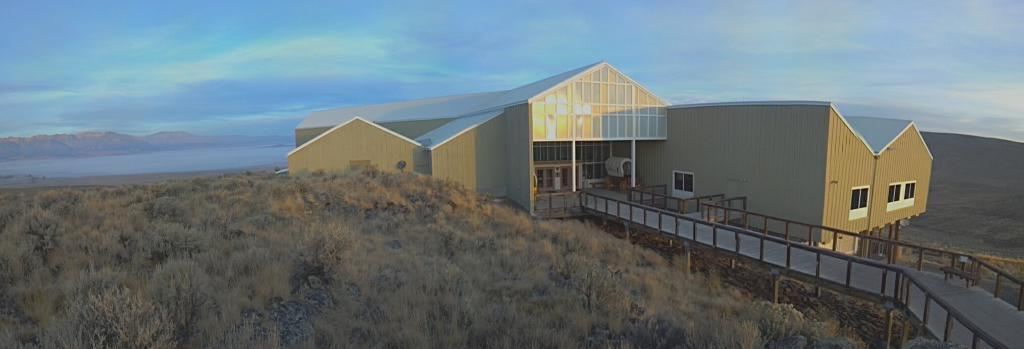What type of structure is the main subject of the image? There is a big house in the image. What can be seen near the house? There are a lot of plants beside the house. Where is the house located? The house is constructed on a hill. What feature is present in front of the house? There is a bridge way in front of the house. What riddle is being solved by the tree in the image? There is no tree present in the image, and therefore no riddle being solved. 